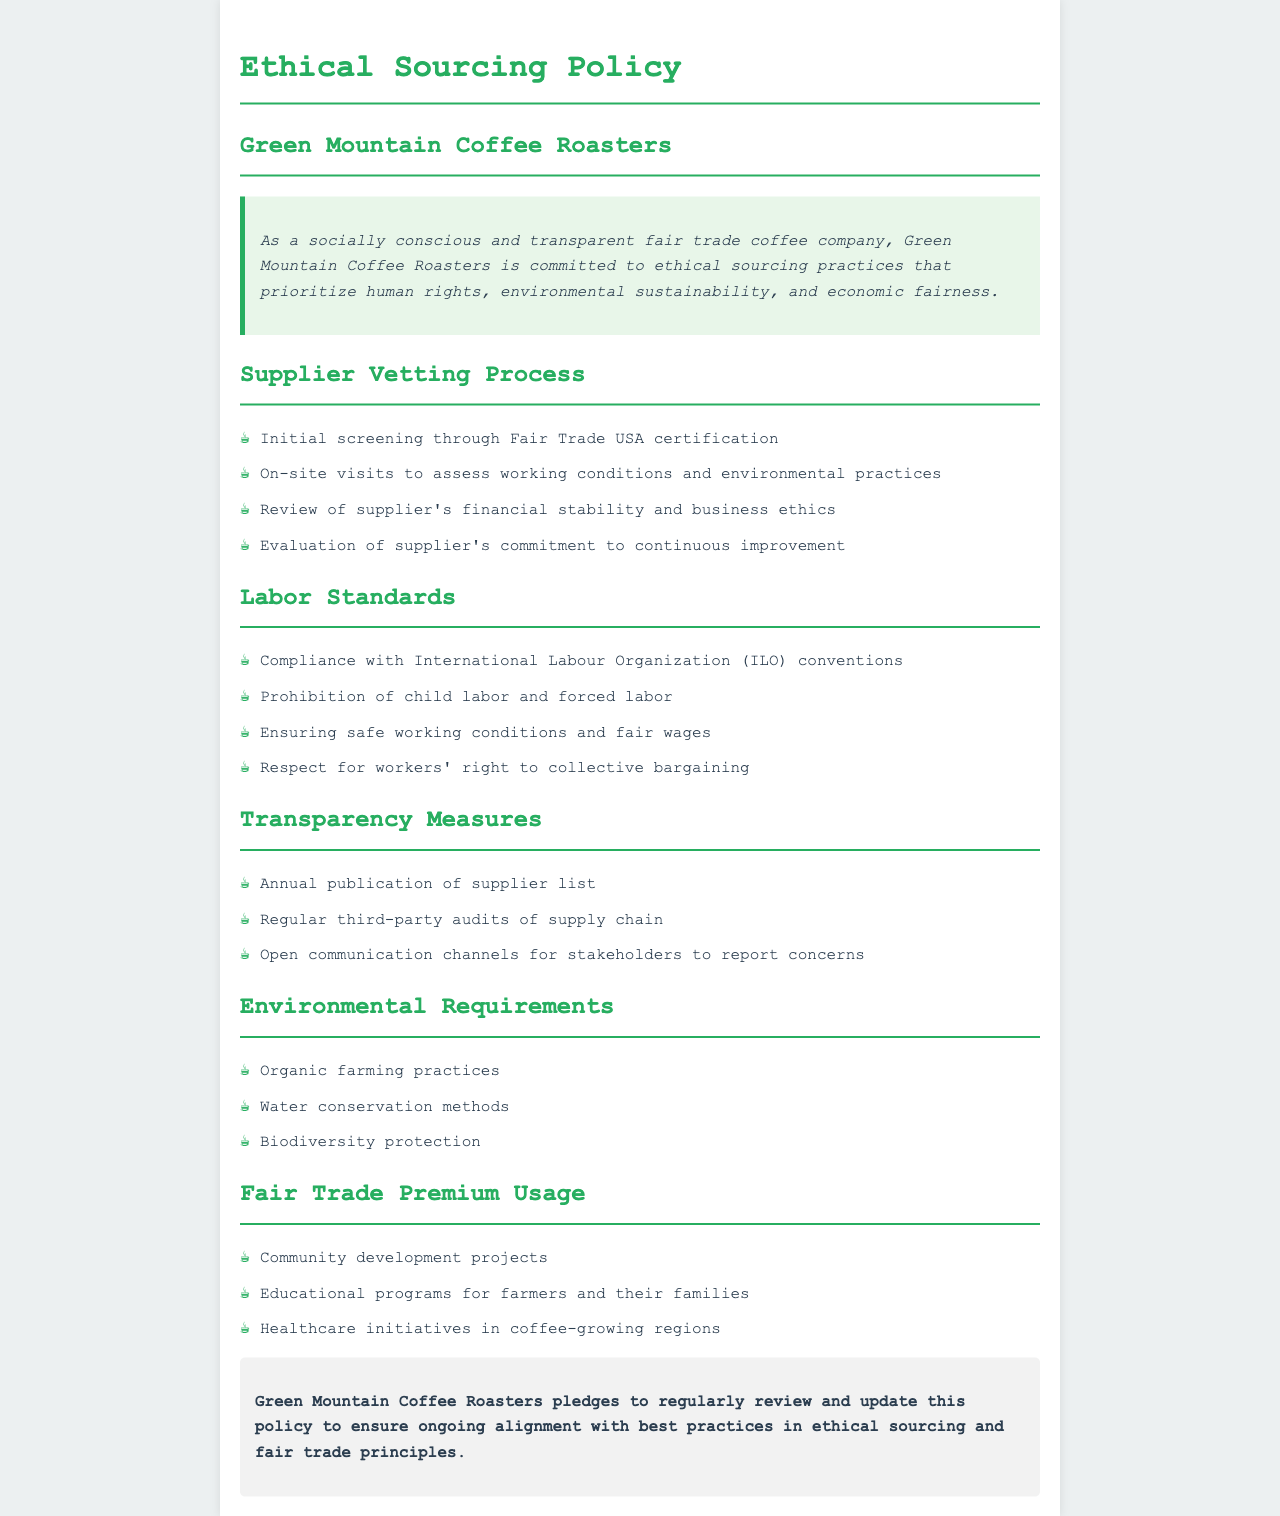what is the main commitment of Green Mountain Coffee Roasters? The main commitment is to ethical sourcing practices that prioritize human rights, environmental sustainability, and economic fairness.
Answer: ethical sourcing practices what certification is used in the initial screening of suppliers? The document states that initial screening is done through Fair Trade USA certification.
Answer: Fair Trade USA certification how does Green Mountain Coffee Roasters assess working conditions? The company performs on-site visits to assess working conditions and environmental practices.
Answer: on-site visits what is the prohibition stated under labor standards? The document specifies the prohibition of child labor and forced labor.
Answer: child labor and forced labor how often does Green Mountain Coffee Roasters publish its supplier list? The document mentions an annual publication of the supplier list.
Answer: annual publication which international organization's conventions must labor standards comply with? Labor standards must comply with International Labour Organization conventions.
Answer: International Labour Organization what are the community-focused projects funded by Fair Trade premiums? The document lists community development projects as one of the uses for Fair Trade premiums.
Answer: community development projects what is one environmental requirement mentioned in the policy? One environmental requirement specified is organic farming practices.
Answer: organic farming practices how does the company ensure transparency in the supply chain? Transparency is ensured through regular third-party audits of the supply chain.
Answer: regular third-party audits 